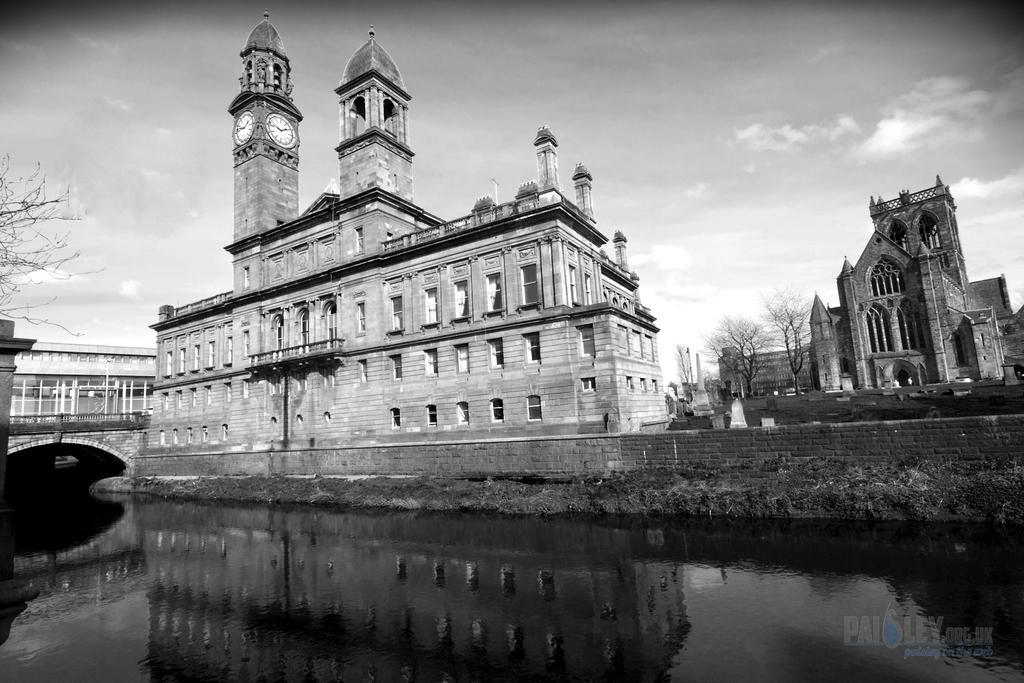How would you summarize this image in a sentence or two? In this picture there are buildings and trees. In the foreground there are clocks on the building. On the left side of the image there is a bridge. At the top there is sky and there are clouds. At the bottom there is grass and there is water and there is a reflection of building on the water. At the bottom right there is text. 